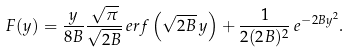Convert formula to latex. <formula><loc_0><loc_0><loc_500><loc_500>F ( y ) & = \frac { y } { 8 B } \frac { \sqrt { \pi } } { \sqrt { 2 B } } \, e r f \left ( \sqrt { 2 B } \, y \right ) + \frac { 1 } { 2 ( 2 B ) ^ { 2 } } \, e ^ { - 2 B y ^ { 2 } } .</formula> 